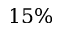<formula> <loc_0><loc_0><loc_500><loc_500>1 5 \%</formula> 